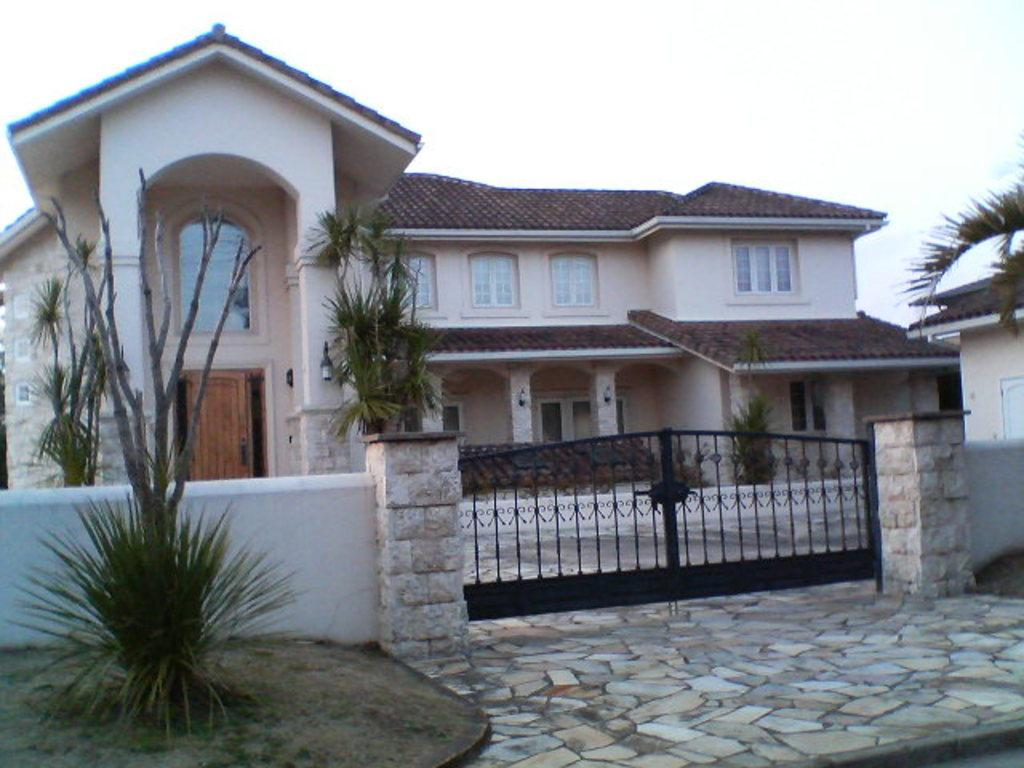What type of structure is present in the image? There is a house in the image. What can be seen beneath the house? The ground is visible in the image. What type of vegetation is present in the image? There is grass, plants, and trees in the image. What is the color of the gate in the image? The gate in the image is black. What is visible above the house? The sky is visible in the image. What type of paste is being used to hold the house together in the image? There is no indication in the image that any paste is being used to hold the house together; it appears to be a solid structure. 